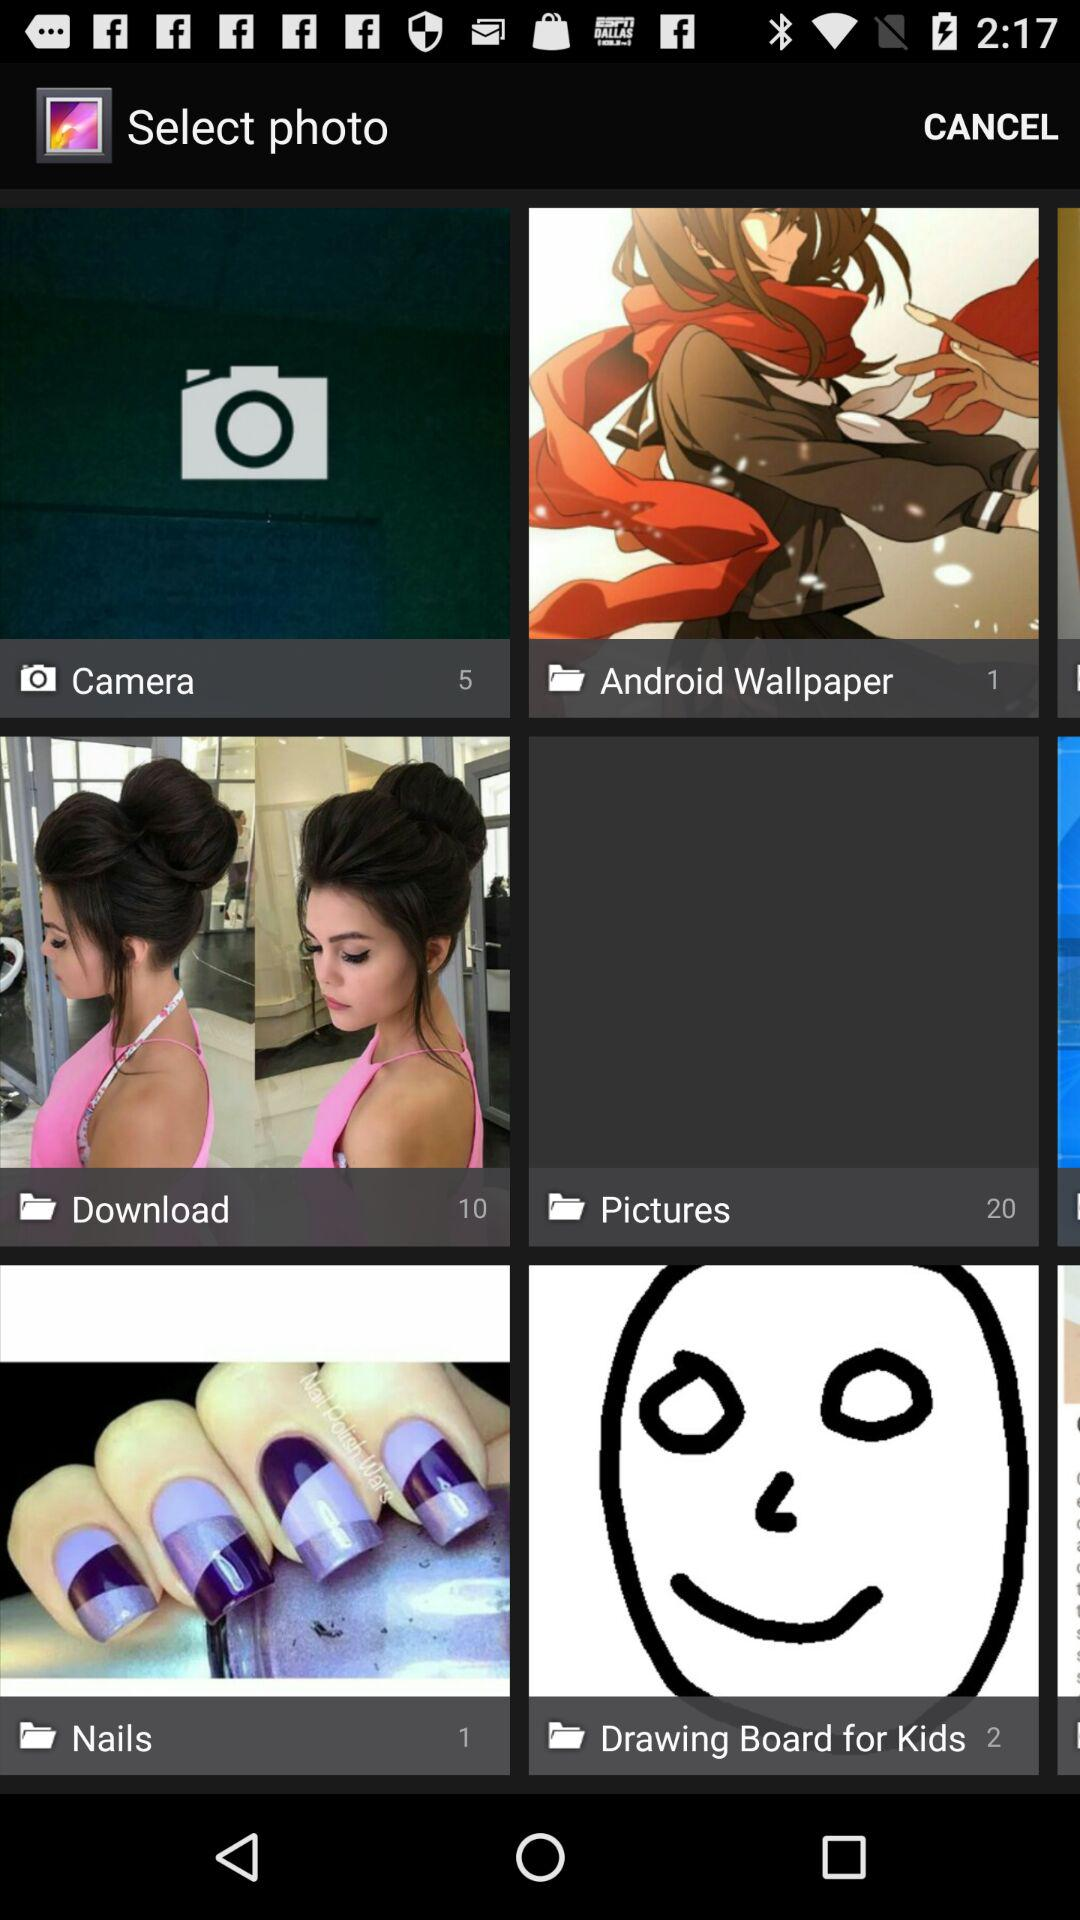How many photos are there in the "Pictures" folder? There are 20 photos. 